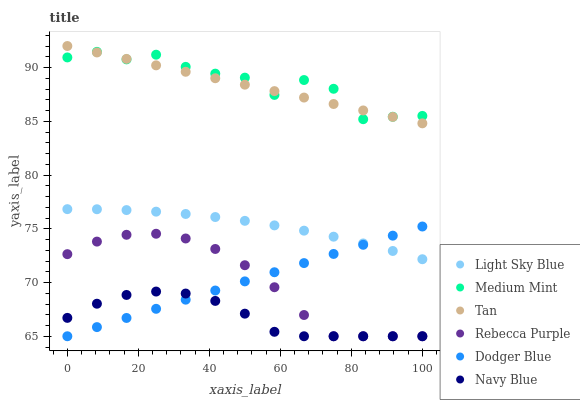Does Navy Blue have the minimum area under the curve?
Answer yes or no. Yes. Does Medium Mint have the maximum area under the curve?
Answer yes or no. Yes. Does Light Sky Blue have the minimum area under the curve?
Answer yes or no. No. Does Light Sky Blue have the maximum area under the curve?
Answer yes or no. No. Is Dodger Blue the smoothest?
Answer yes or no. Yes. Is Medium Mint the roughest?
Answer yes or no. Yes. Is Navy Blue the smoothest?
Answer yes or no. No. Is Navy Blue the roughest?
Answer yes or no. No. Does Navy Blue have the lowest value?
Answer yes or no. Yes. Does Light Sky Blue have the lowest value?
Answer yes or no. No. Does Tan have the highest value?
Answer yes or no. Yes. Does Light Sky Blue have the highest value?
Answer yes or no. No. Is Dodger Blue less than Tan?
Answer yes or no. Yes. Is Medium Mint greater than Rebecca Purple?
Answer yes or no. Yes. Does Dodger Blue intersect Rebecca Purple?
Answer yes or no. Yes. Is Dodger Blue less than Rebecca Purple?
Answer yes or no. No. Is Dodger Blue greater than Rebecca Purple?
Answer yes or no. No. Does Dodger Blue intersect Tan?
Answer yes or no. No. 